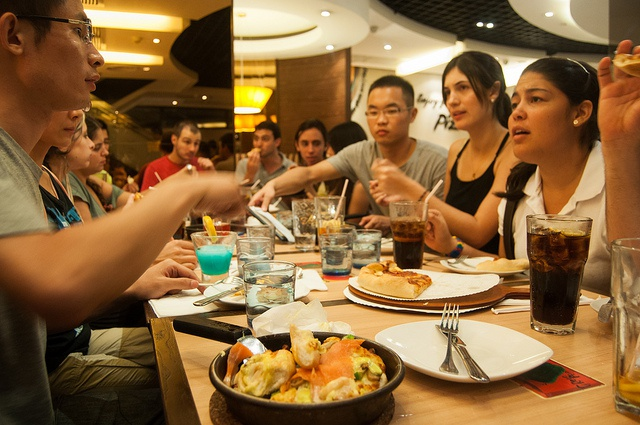Describe the objects in this image and their specific colors. I can see dining table in black, tan, and olive tones, people in black, maroon, brown, and tan tones, people in black, brown, maroon, and tan tones, bowl in black, orange, and olive tones, and people in black, brown, orange, and maroon tones in this image. 